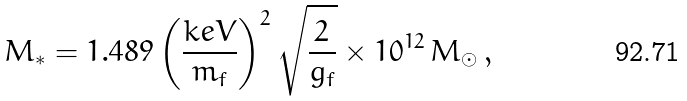<formula> <loc_0><loc_0><loc_500><loc_500>M _ { * } = 1 . 4 8 9 \left ( \frac { k e V } { m _ { f } } \right ) ^ { 2 } \sqrt { \frac { 2 } { g _ { f } } } \times 1 0 ^ { 1 2 } \, M _ { \odot } \, ,</formula> 